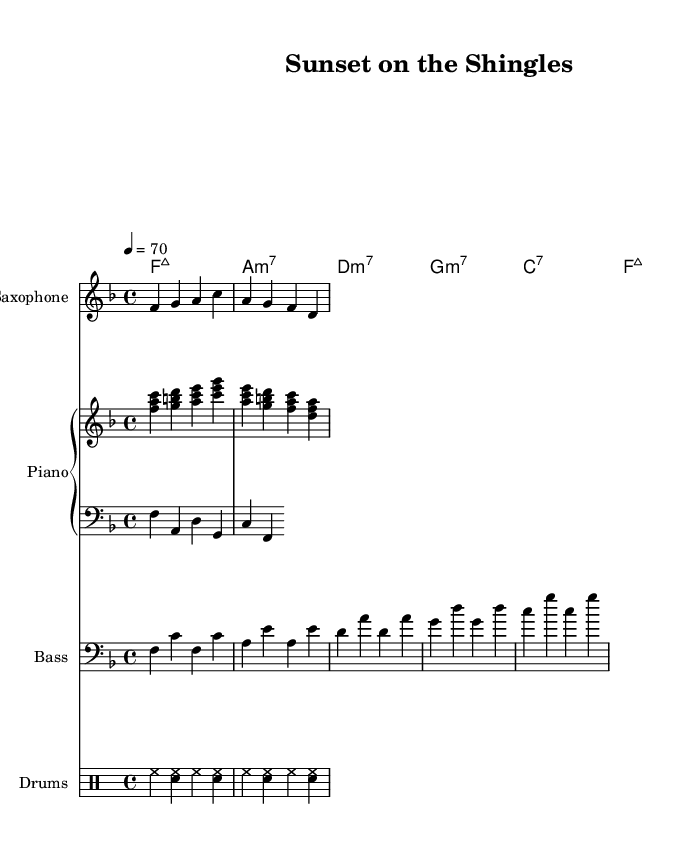What is the key signature of this music? The key signature is F major, indicated by one flat (B flat).
Answer: F major What is the time signature of this piece? The time signature is 4/4, meaning there are four beats in each measure.
Answer: 4/4 What is the tempo marking for this composition? The tempo marking is set at 70 beats per minute.
Answer: 70 How many measures are represented in the sheet music? There are several measures, and by counting the number of times the bar lines appear, we find the total. The music includes 8 measures.
Answer: 8 Which instrument plays the melody in this score? The melody is played by the saxophone as indicated by the instrument name.
Answer: Saxophone What type of seventh chord is used for the first chord? The first chord shown is an F major seventh chord (notated as F:maj7).
Answer: F:maj7 What is the purpose of the drum part in this jazz piece? The drum part provides rhythm and keeps the tempo steady, serving as a foundation for the other instruments.
Answer: Rhythm 